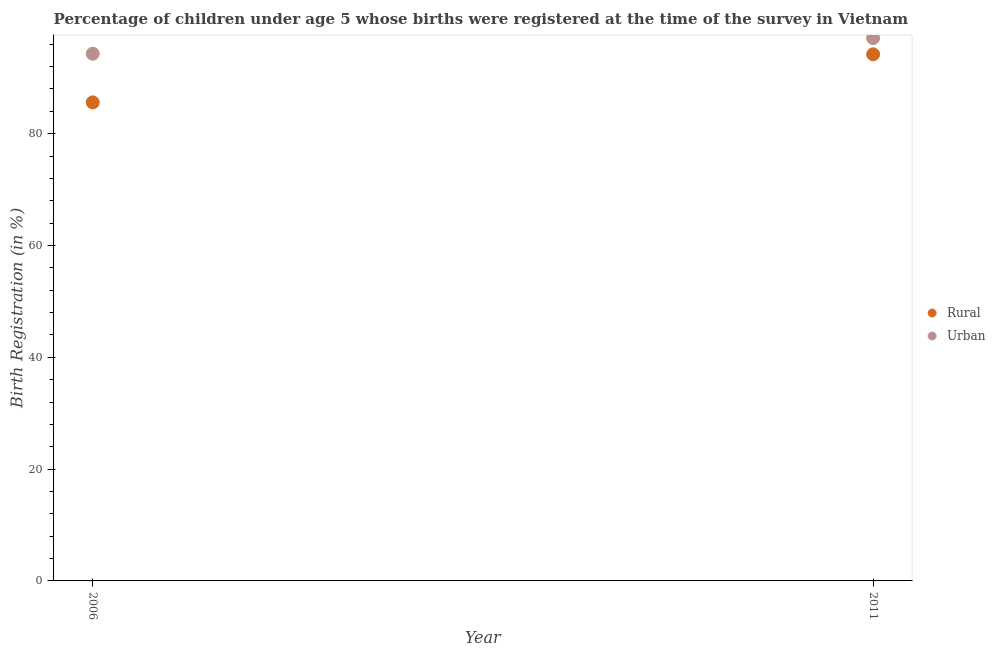What is the rural birth registration in 2011?
Offer a very short reply. 94.2. Across all years, what is the maximum rural birth registration?
Keep it short and to the point. 94.2. Across all years, what is the minimum rural birth registration?
Your answer should be compact. 85.6. What is the total urban birth registration in the graph?
Offer a terse response. 191.4. What is the difference between the urban birth registration in 2006 and that in 2011?
Give a very brief answer. -2.8. What is the difference between the urban birth registration in 2011 and the rural birth registration in 2006?
Your answer should be very brief. 11.5. What is the average urban birth registration per year?
Give a very brief answer. 95.7. In the year 2006, what is the difference between the urban birth registration and rural birth registration?
Keep it short and to the point. 8.7. What is the ratio of the urban birth registration in 2006 to that in 2011?
Your answer should be compact. 0.97. Is the urban birth registration strictly greater than the rural birth registration over the years?
Your answer should be compact. Yes. How many years are there in the graph?
Provide a short and direct response. 2. Does the graph contain any zero values?
Offer a terse response. No. Does the graph contain grids?
Make the answer very short. No. How many legend labels are there?
Your response must be concise. 2. How are the legend labels stacked?
Your response must be concise. Vertical. What is the title of the graph?
Provide a short and direct response. Percentage of children under age 5 whose births were registered at the time of the survey in Vietnam. Does "Techinal cooperation" appear as one of the legend labels in the graph?
Offer a terse response. No. What is the label or title of the X-axis?
Offer a very short reply. Year. What is the label or title of the Y-axis?
Keep it short and to the point. Birth Registration (in %). What is the Birth Registration (in %) in Rural in 2006?
Offer a very short reply. 85.6. What is the Birth Registration (in %) in Urban in 2006?
Provide a short and direct response. 94.3. What is the Birth Registration (in %) of Rural in 2011?
Offer a terse response. 94.2. What is the Birth Registration (in %) in Urban in 2011?
Your answer should be compact. 97.1. Across all years, what is the maximum Birth Registration (in %) in Rural?
Provide a short and direct response. 94.2. Across all years, what is the maximum Birth Registration (in %) of Urban?
Your answer should be compact. 97.1. Across all years, what is the minimum Birth Registration (in %) of Rural?
Give a very brief answer. 85.6. Across all years, what is the minimum Birth Registration (in %) of Urban?
Provide a short and direct response. 94.3. What is the total Birth Registration (in %) in Rural in the graph?
Ensure brevity in your answer.  179.8. What is the total Birth Registration (in %) in Urban in the graph?
Provide a succinct answer. 191.4. What is the difference between the Birth Registration (in %) in Rural in 2006 and the Birth Registration (in %) in Urban in 2011?
Your response must be concise. -11.5. What is the average Birth Registration (in %) in Rural per year?
Provide a short and direct response. 89.9. What is the average Birth Registration (in %) in Urban per year?
Offer a terse response. 95.7. What is the ratio of the Birth Registration (in %) of Rural in 2006 to that in 2011?
Your answer should be very brief. 0.91. What is the ratio of the Birth Registration (in %) in Urban in 2006 to that in 2011?
Your answer should be very brief. 0.97. What is the difference between the highest and the second highest Birth Registration (in %) of Urban?
Your answer should be compact. 2.8. What is the difference between the highest and the lowest Birth Registration (in %) of Rural?
Give a very brief answer. 8.6. 